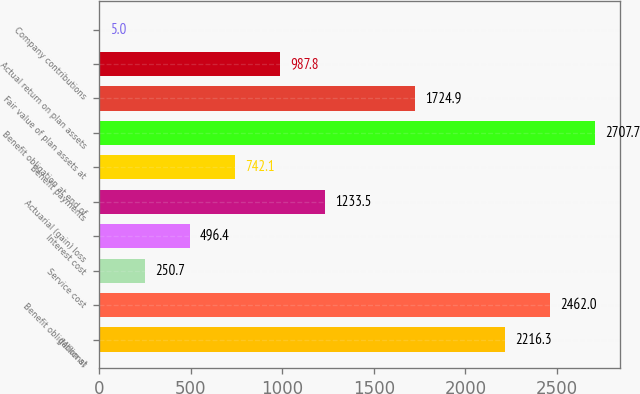Convert chart to OTSL. <chart><loc_0><loc_0><loc_500><loc_500><bar_chart><fcel>(Millions)<fcel>Benefit obligation at<fcel>Service cost<fcel>Interest cost<fcel>Actuarial (gain) loss<fcel>Benefit payments<fcel>Benefit obligation at end of<fcel>Fair value of plan assets at<fcel>Actual return on plan assets<fcel>Company contributions<nl><fcel>2216.3<fcel>2462<fcel>250.7<fcel>496.4<fcel>1233.5<fcel>742.1<fcel>2707.7<fcel>1724.9<fcel>987.8<fcel>5<nl></chart> 